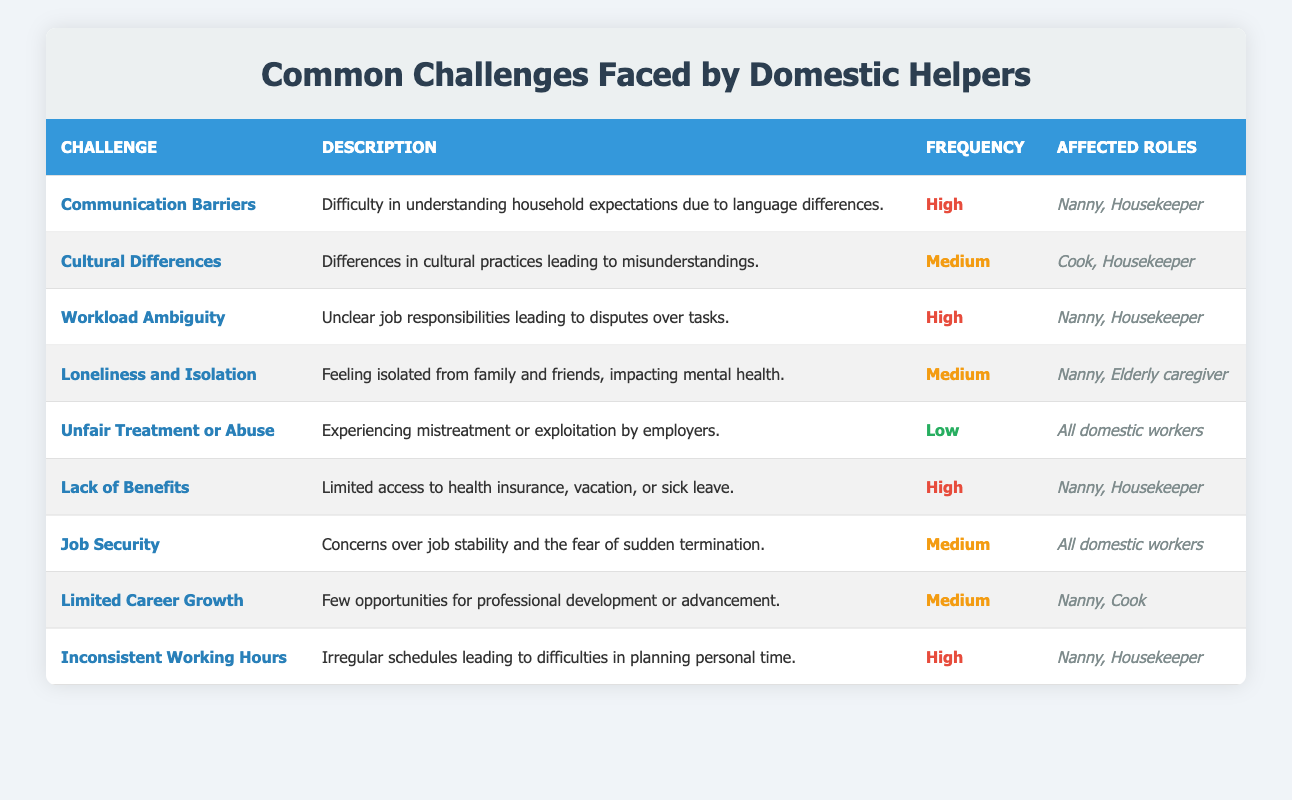What is the most common challenge faced by domestic helpers? Referring to the frequency column, "Communication Barriers," "Workload Ambiguity," "Lack of Benefits," and "Inconsistent Working Hours" are marked as high frequency challenges, but "Communication Barriers" appears first in the list, so it is the most common challenge mentioned.
Answer: Communication Barriers How many challenges have a medium frequency? By checking the frequency column, there are three challenges listed with "Medium" frequency: "Cultural Differences," "Loneliness and Isolation," "Job Security," and "Limited Career Growth." Thus, the count is 4.
Answer: 4 Which roles are affected by the challenge of "Unfair Treatment or Abuse"? The affected roles for this challenge is stated in the affected roles column as "All domestic workers."
Answer: All domestic workers Does "Loneliness and Isolation" affect Nannies? According to the affected roles for "Loneliness and Isolation," they include "Nanny," indicating that this challenge does affect Nannies.
Answer: Yes What percentage of challenges have been marked as high frequency? There are 9 challenges in total. Four of them are high frequency: "Communication Barriers," "Workload Ambiguity," "Lack of Benefits," and "Inconsistent Working Hours." Therefore, to find the percentage: (4/9) × 100 = approximately 44.44%.
Answer: Approximately 44.44% List all challenges that affect Housekeepers. The challenges affecting Housekeepers, as shown in the affected roles column, include "Communication Barriers," "Cultural Differences," "Workload Ambiguity," "Lack of Benefits," "Inconsistent Working Hours." Therefore, these five challenges concern Housekeepers.
Answer: Communication Barriers, Cultural Differences, Workload Ambiguity, Lack of Benefits, Inconsistent Working Hours What is the least common challenge faced by domestic helpers based on frequency? Referring to the frequency column, "Unfair Treatment or Abuse" is marked as "Low," indicating it's the least common challenge noted among those listed.
Answer: Unfair Treatment or Abuse How many different roles are affected by high-frequency challenges? The high-frequency challenges include "Communication Barriers," "Workload Ambiguity," "Lack of Benefits," and "Inconsistent Working Hours." The affected roles for these challenges are "Nanny," "Housekeeper," and "All domestic workers." Counting distinct roles yields "Nanny," "Housekeeper," and one role covering all workers, which is mainly "All." So, the roles are 3.
Answer: 3 Is the challenge "Limited Career Growth" marked as high frequency? Cross-referencing in the frequency column, "Limited Career Growth" is marked as "Medium," therefore it is not categorized as high frequency.
Answer: No Which challenge impacts mental health and affects live-in helpers? The challenge "Loneliness and Isolation" specifically addresses the mental health impact and includes "Live-in helpers" in the impacted groups.
Answer: Loneliness and Isolation 